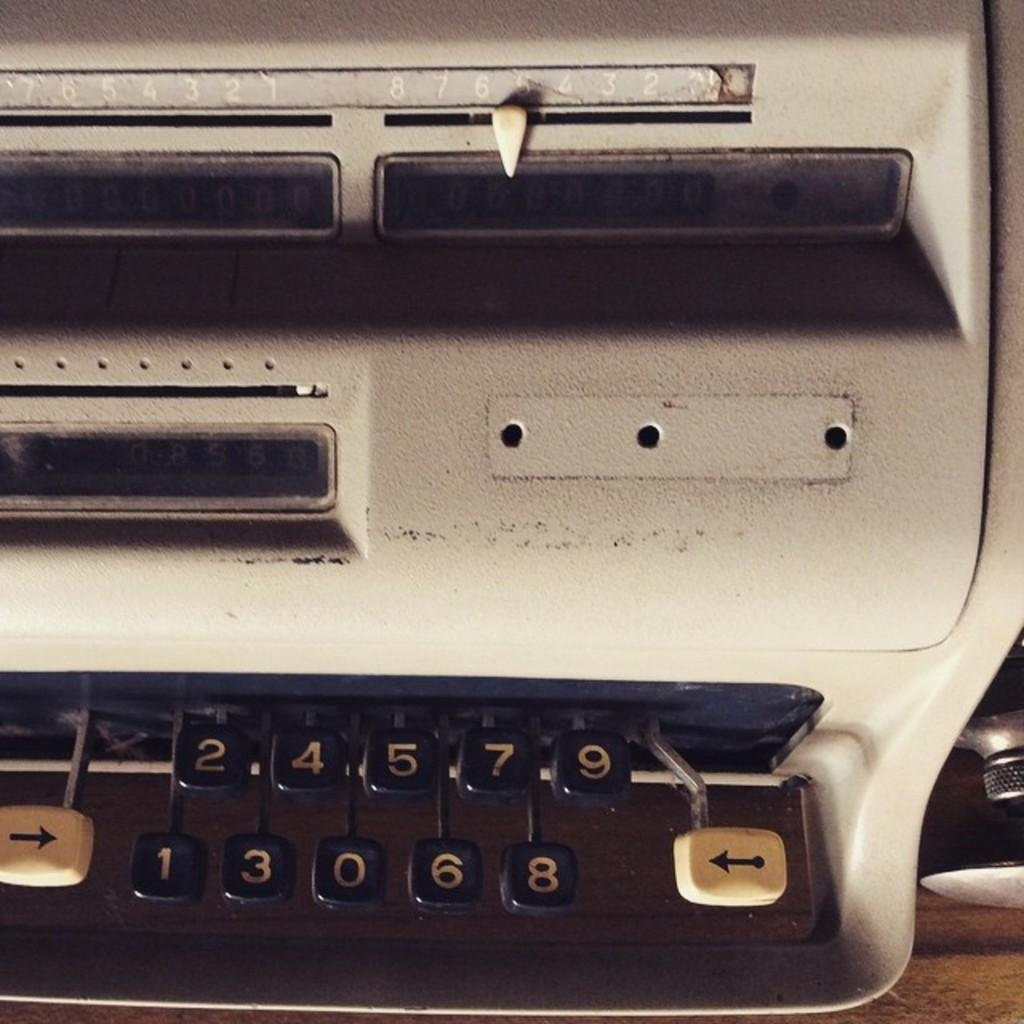What is the main object in the image? There is a typewriter machine in the image. Can you describe the typewriter machine in more detail? The typewriter machine is a device used for typing text onto paper. What might someone use the typewriter machine for? Someone might use the typewriter machine for writing letters, documents, or stories. What type of wool is being spun on the typewriter machine in the image? There is no wool or spinning activity present in the image; it features a typewriter machine. 